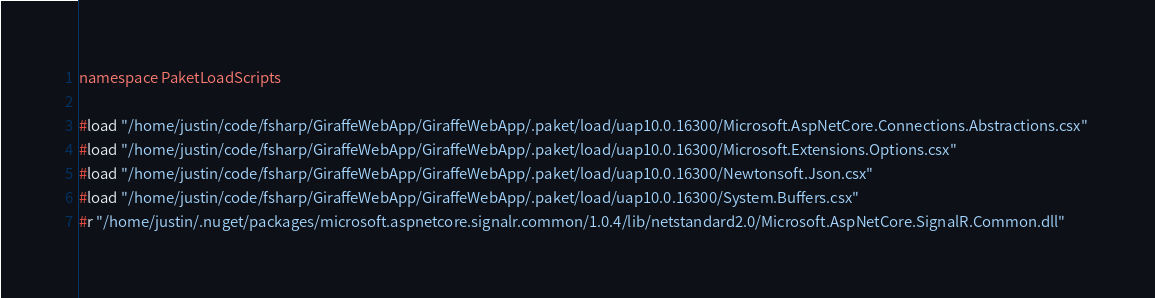<code> <loc_0><loc_0><loc_500><loc_500><_C#_>namespace PaketLoadScripts

#load "/home/justin/code/fsharp/GiraffeWebApp/GiraffeWebApp/.paket/load/uap10.0.16300/Microsoft.AspNetCore.Connections.Abstractions.csx" 
#load "/home/justin/code/fsharp/GiraffeWebApp/GiraffeWebApp/.paket/load/uap10.0.16300/Microsoft.Extensions.Options.csx" 
#load "/home/justin/code/fsharp/GiraffeWebApp/GiraffeWebApp/.paket/load/uap10.0.16300/Newtonsoft.Json.csx" 
#load "/home/justin/code/fsharp/GiraffeWebApp/GiraffeWebApp/.paket/load/uap10.0.16300/System.Buffers.csx" 
#r "/home/justin/.nuget/packages/microsoft.aspnetcore.signalr.common/1.0.4/lib/netstandard2.0/Microsoft.AspNetCore.SignalR.Common.dll" </code> 